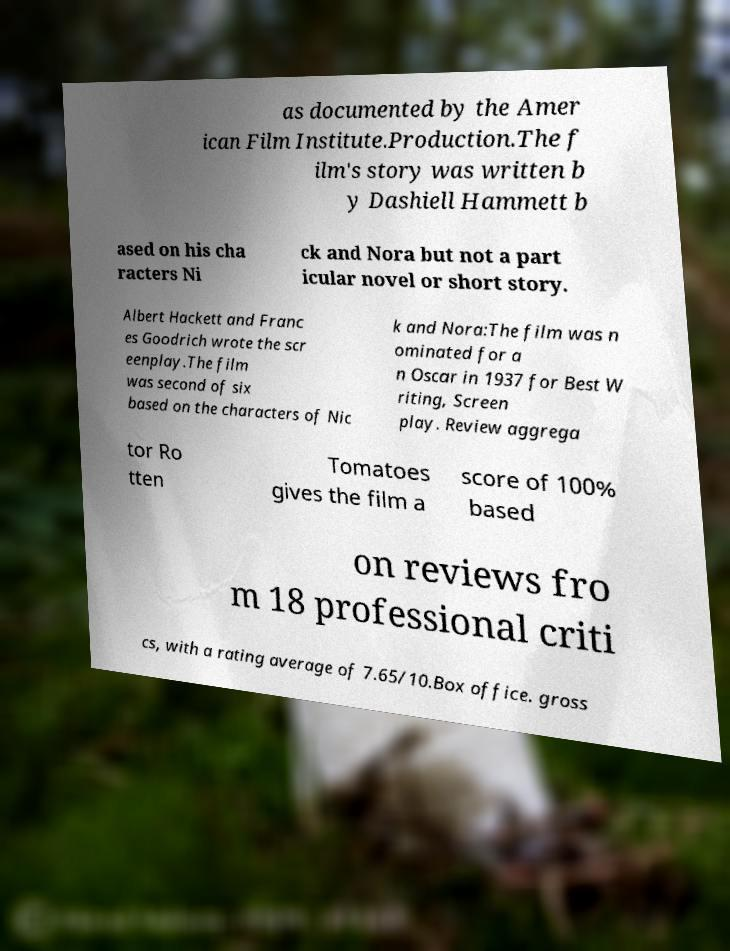Could you assist in decoding the text presented in this image and type it out clearly? as documented by the Amer ican Film Institute.Production.The f ilm's story was written b y Dashiell Hammett b ased on his cha racters Ni ck and Nora but not a part icular novel or short story. Albert Hackett and Franc es Goodrich wrote the scr eenplay.The film was second of six based on the characters of Nic k and Nora:The film was n ominated for a n Oscar in 1937 for Best W riting, Screen play. Review aggrega tor Ro tten Tomatoes gives the film a score of 100% based on reviews fro m 18 professional criti cs, with a rating average of 7.65/10.Box office. gross 